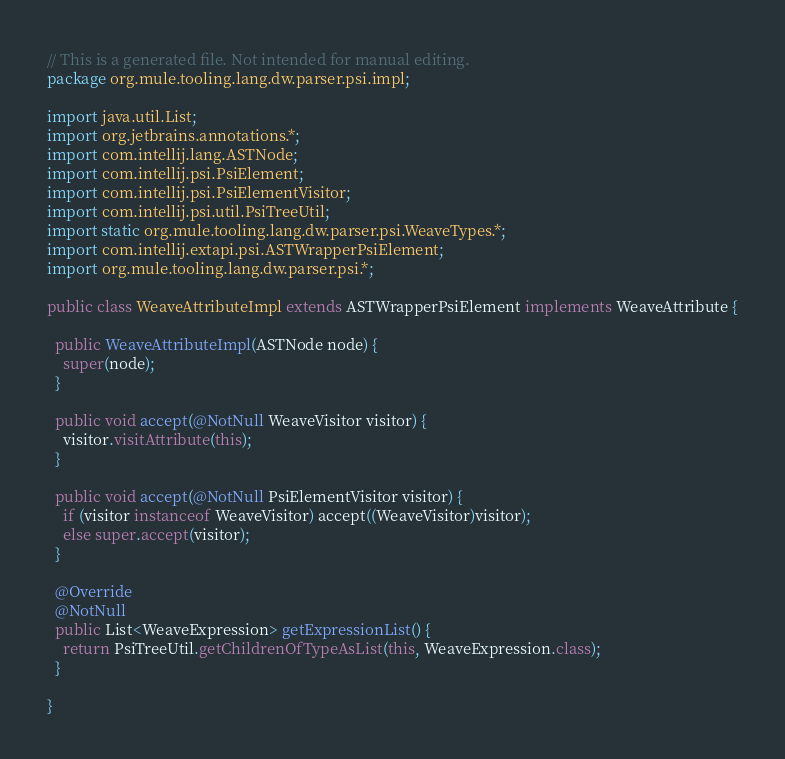<code> <loc_0><loc_0><loc_500><loc_500><_Java_>// This is a generated file. Not intended for manual editing.
package org.mule.tooling.lang.dw.parser.psi.impl;

import java.util.List;
import org.jetbrains.annotations.*;
import com.intellij.lang.ASTNode;
import com.intellij.psi.PsiElement;
import com.intellij.psi.PsiElementVisitor;
import com.intellij.psi.util.PsiTreeUtil;
import static org.mule.tooling.lang.dw.parser.psi.WeaveTypes.*;
import com.intellij.extapi.psi.ASTWrapperPsiElement;
import org.mule.tooling.lang.dw.parser.psi.*;

public class WeaveAttributeImpl extends ASTWrapperPsiElement implements WeaveAttribute {

  public WeaveAttributeImpl(ASTNode node) {
    super(node);
  }

  public void accept(@NotNull WeaveVisitor visitor) {
    visitor.visitAttribute(this);
  }

  public void accept(@NotNull PsiElementVisitor visitor) {
    if (visitor instanceof WeaveVisitor) accept((WeaveVisitor)visitor);
    else super.accept(visitor);
  }

  @Override
  @NotNull
  public List<WeaveExpression> getExpressionList() {
    return PsiTreeUtil.getChildrenOfTypeAsList(this, WeaveExpression.class);
  }

}
</code> 